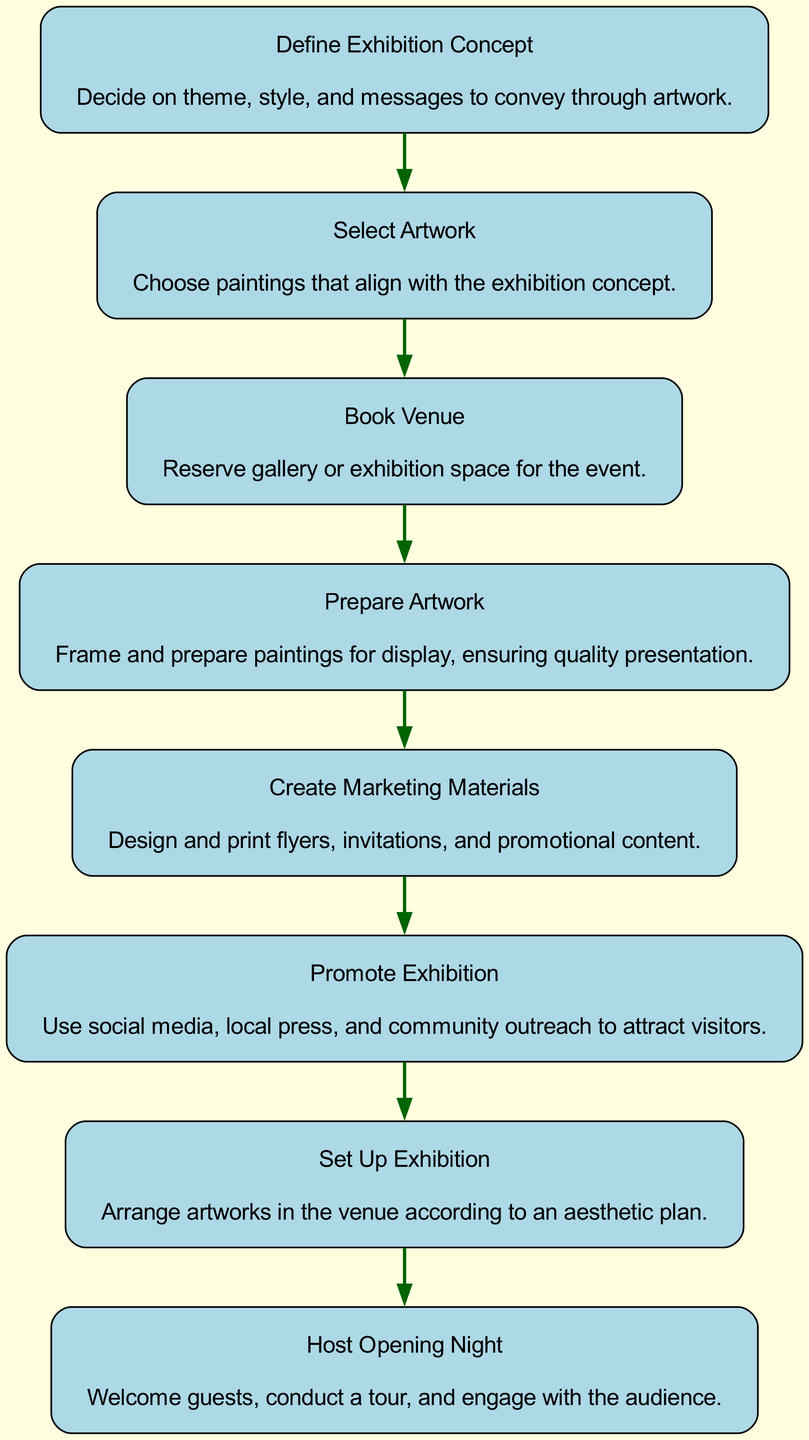What is the first event in the sequence? The first event listed in the sequence is "Define Exhibition Concept," which is the initial step towards setting up the painting exhibition.
Answer: Define Exhibition Concept How many total events are there in the sequence? By counting the events listed in the sequence, there are a total of eight distinct events from conceptualization to opening night.
Answer: 8 What event precedes "Promote Exhibition"? "Create Marketing Materials" directly precedes "Promote Exhibition" in the sequence, indicating that marketing materials must be ready before promotion can begin.
Answer: Create Marketing Materials Which event involves engaging with the audience? The final event "Host Opening Night" is specifically about welcoming guests and engaging with them, which includes conducting a tour and audience interaction.
Answer: Host Opening Night What is the last event in the sequence? The last event in the sequence is "Host Opening Night," marking the culmination of the preparation process for the painting exhibition.
Answer: Host Opening Night What is the relationship between "Select Artwork" and "Prepare Artwork"? "Select Artwork" must occur before "Prepare Artwork" because the artworks need to be chosen first before any preparation can take place.
Answer: Select Artwork precedes Prepare Artwork What must happen directly after "Book Venue"? After "Book Venue," the next event that occurs is "Prepare Artwork," indicating that securing a venue is followed by making the artwork ready for display.
Answer: Prepare Artwork What is emphasized in the "Define Exhibition Concept" event? The emphasis in the "Define Exhibition Concept" event is on deciding the theme, style, and messages that the artwork will convey, setting the foundation for the entire exhibition.
Answer: Decide on theme, style, and messages 